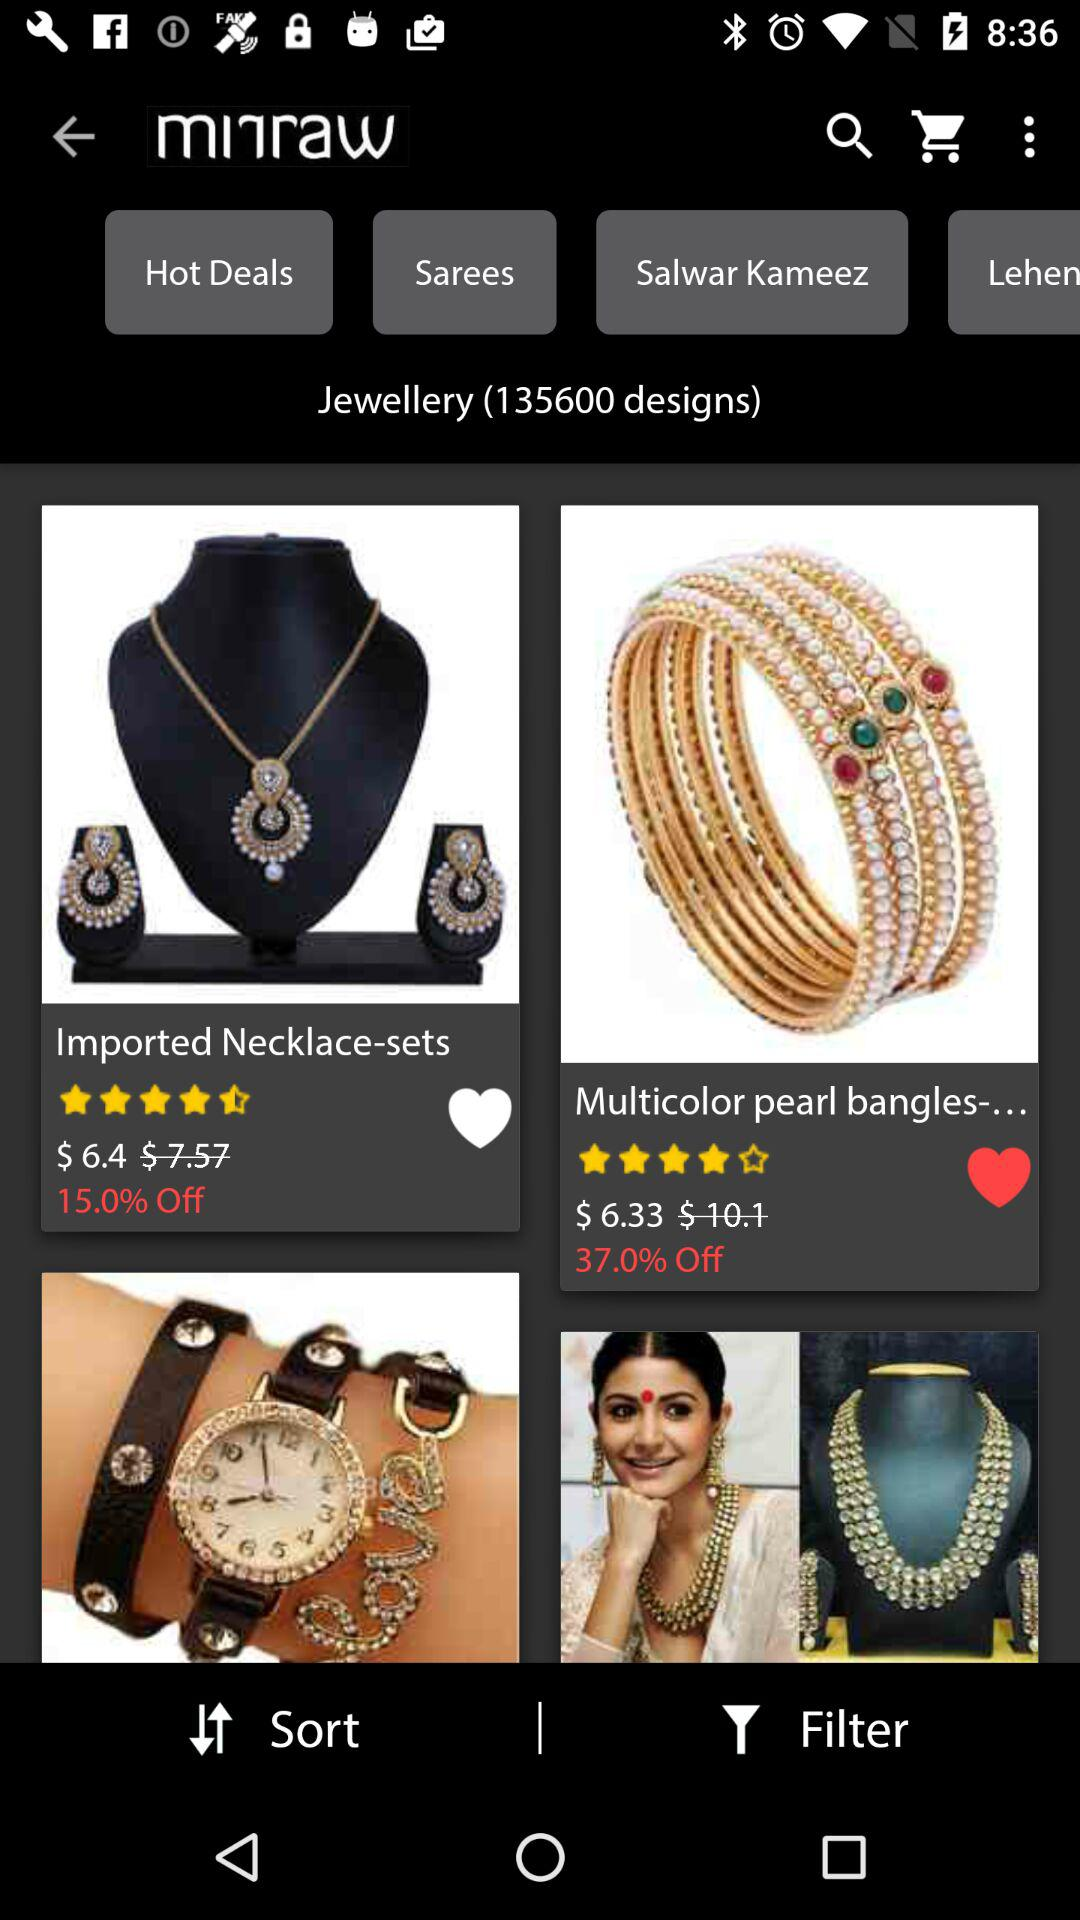What percentage is off on the bangles? There is 37% off. 